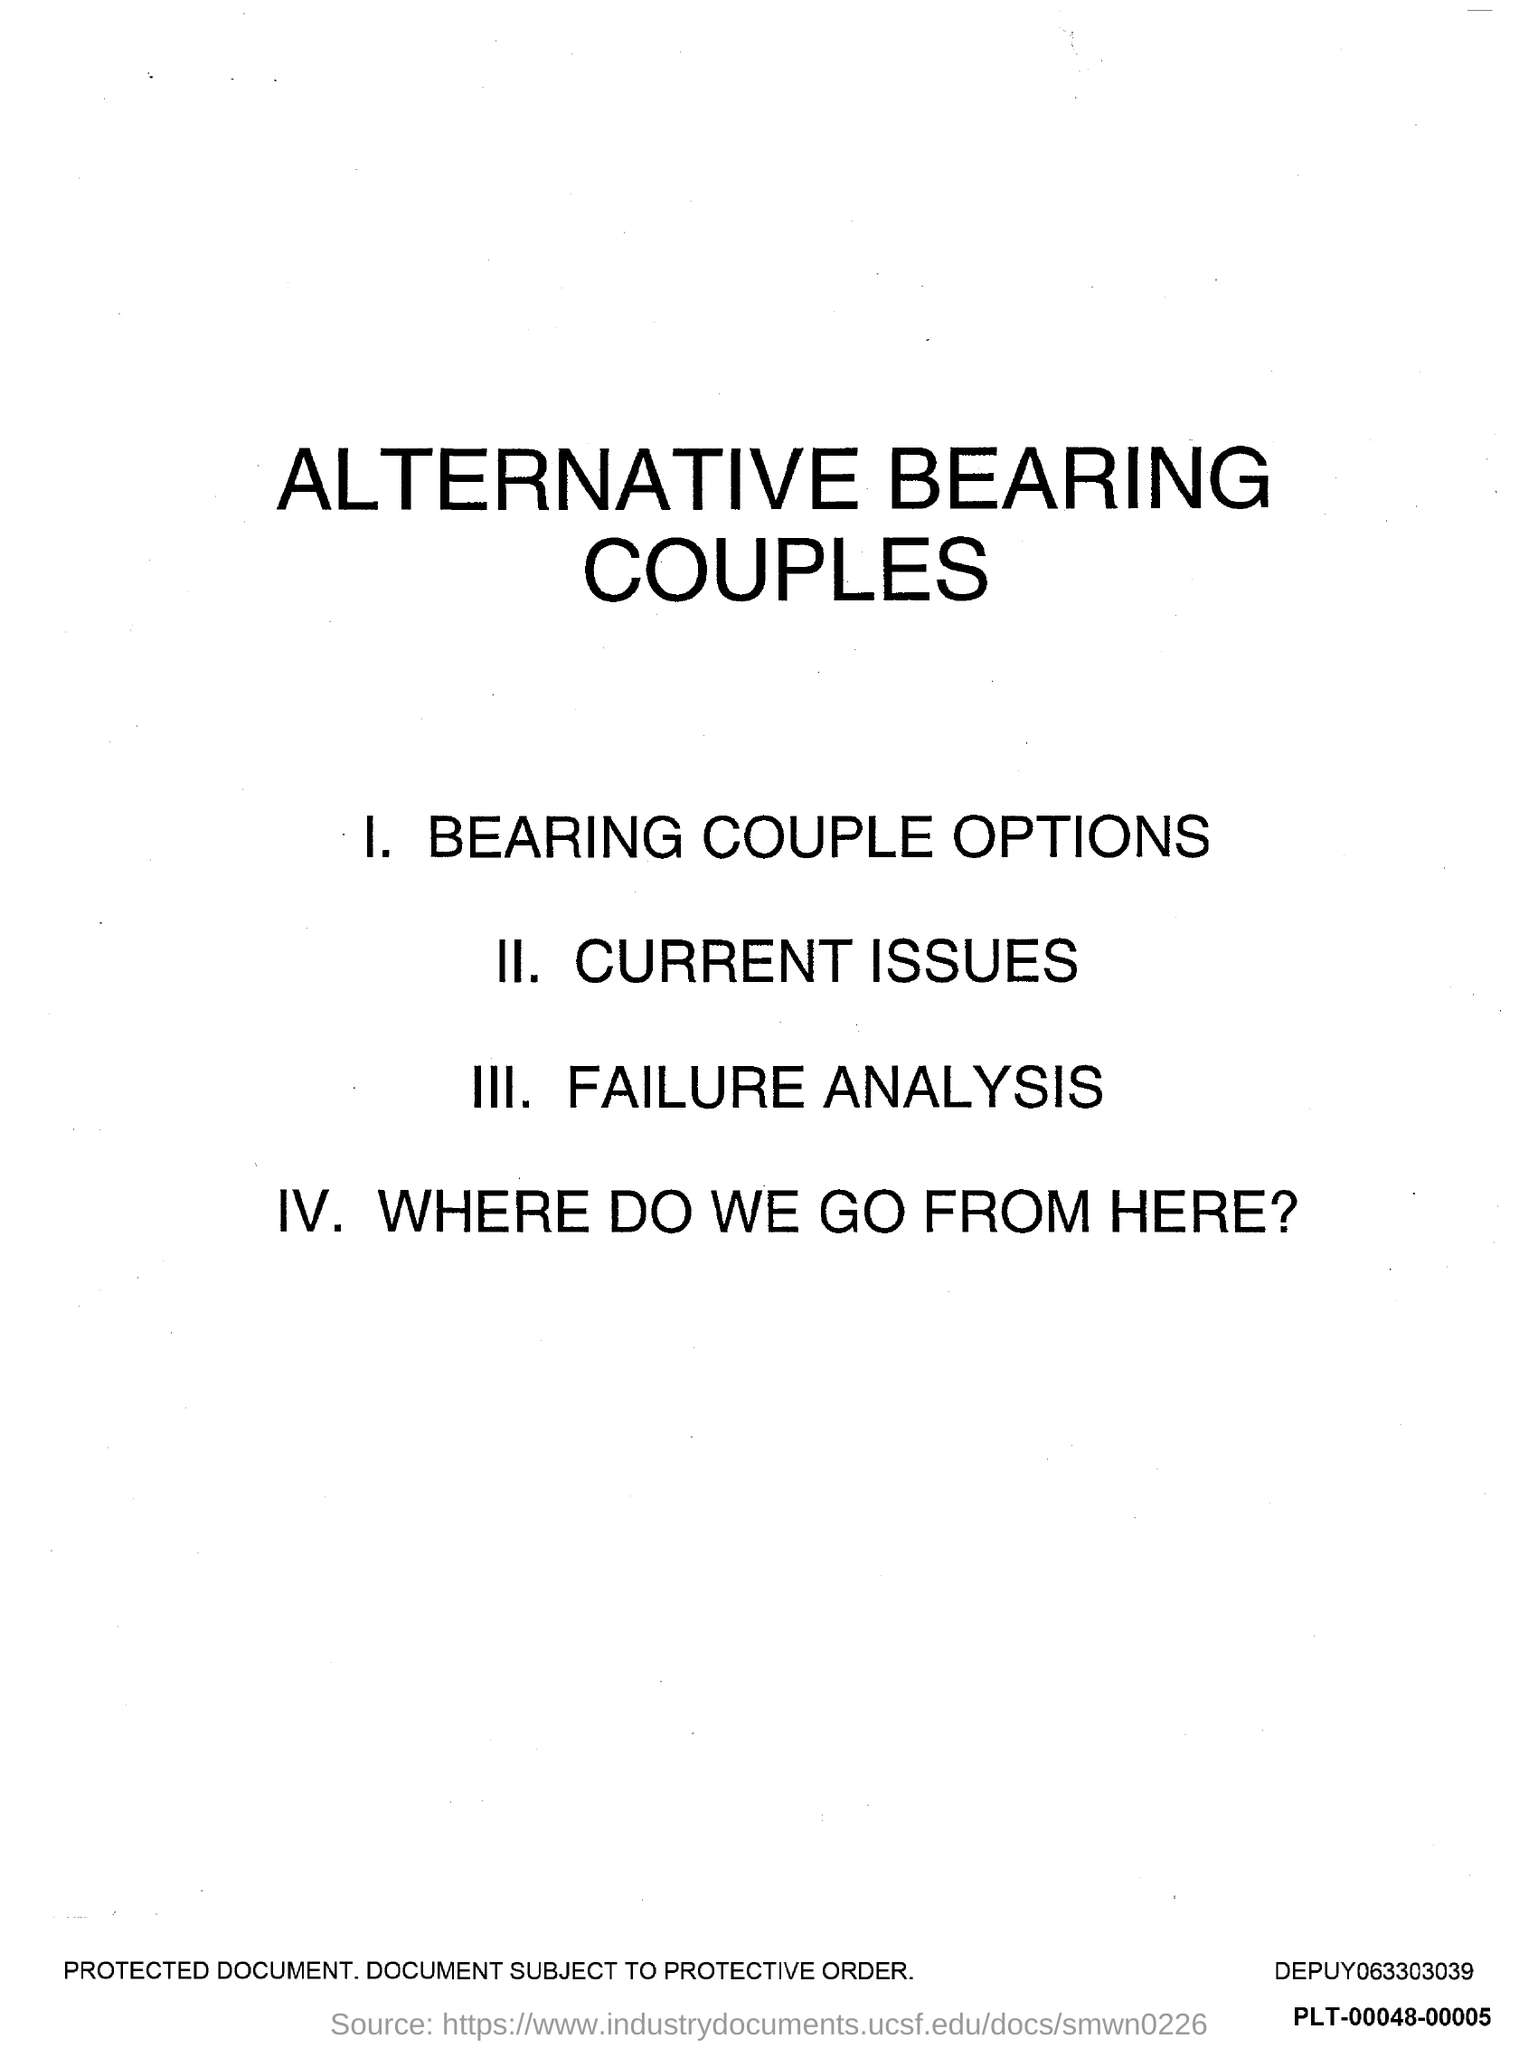Indicate a few pertinent items in this graphic. The document in question is titled "Alternative Bearing Couples. 